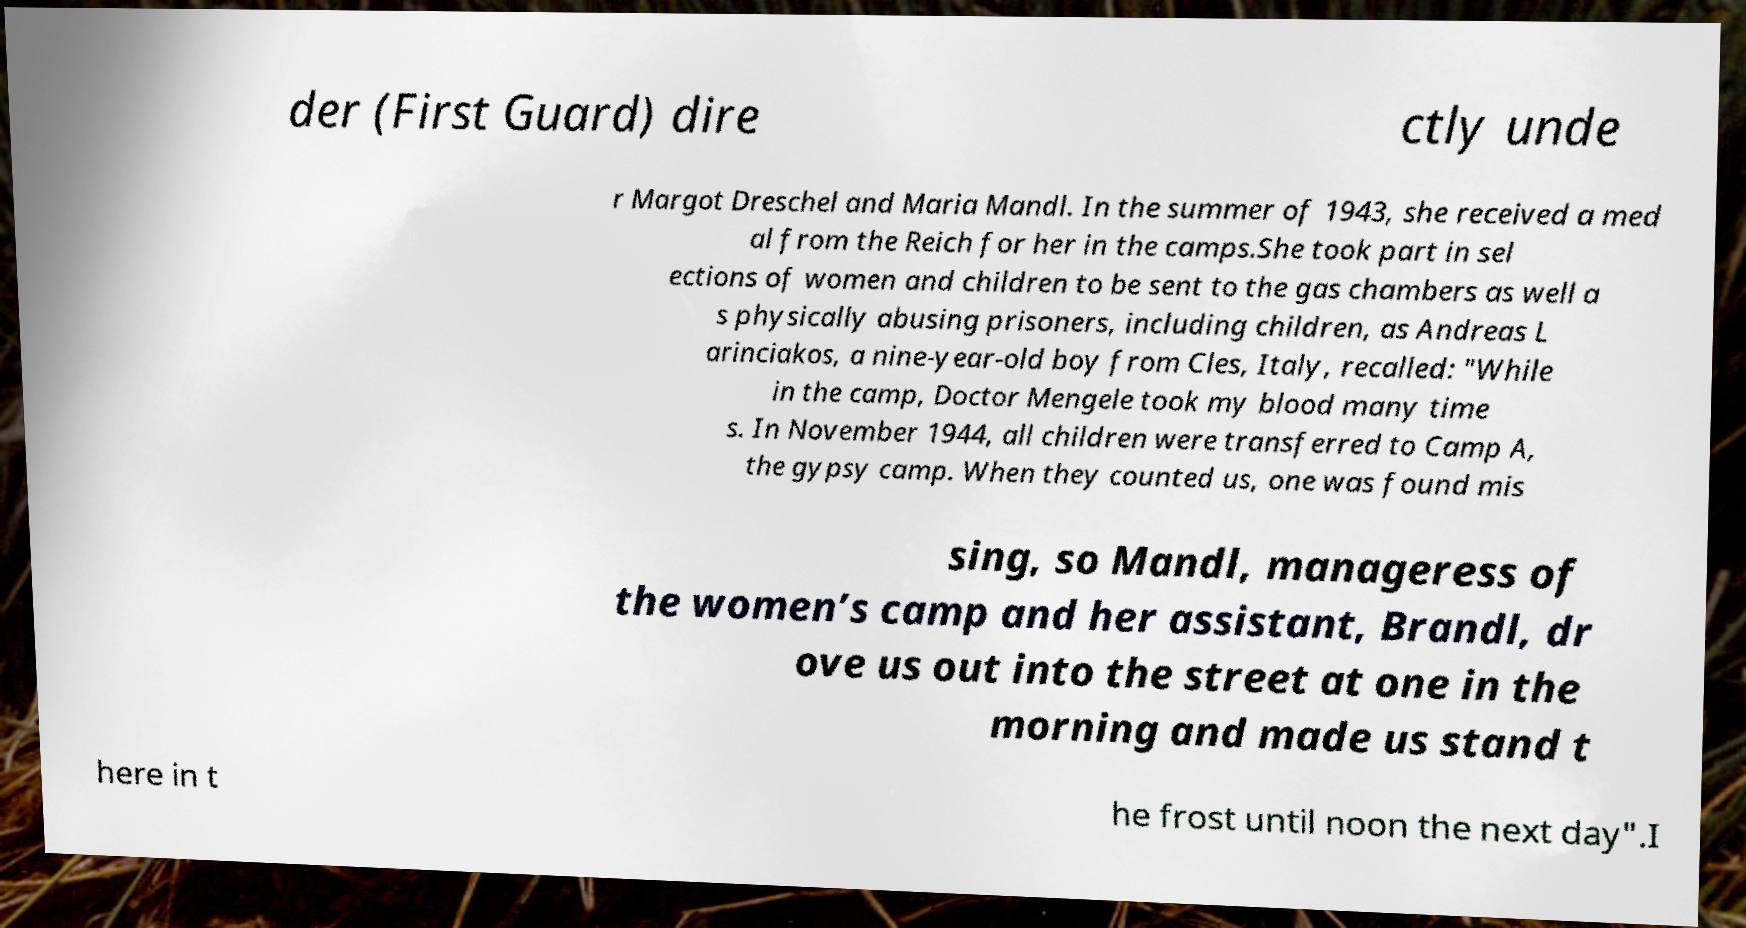What messages or text are displayed in this image? I need them in a readable, typed format. der (First Guard) dire ctly unde r Margot Dreschel and Maria Mandl. In the summer of 1943, she received a med al from the Reich for her in the camps.She took part in sel ections of women and children to be sent to the gas chambers as well a s physically abusing prisoners, including children, as Andreas L arinciakos, a nine-year-old boy from Cles, Italy, recalled: "While in the camp, Doctor Mengele took my blood many time s. In November 1944, all children were transferred to Camp A, the gypsy camp. When they counted us, one was found mis sing, so Mandl, manageress of the women’s camp and her assistant, Brandl, dr ove us out into the street at one in the morning and made us stand t here in t he frost until noon the next day".I 